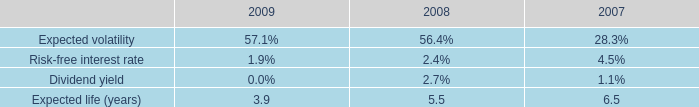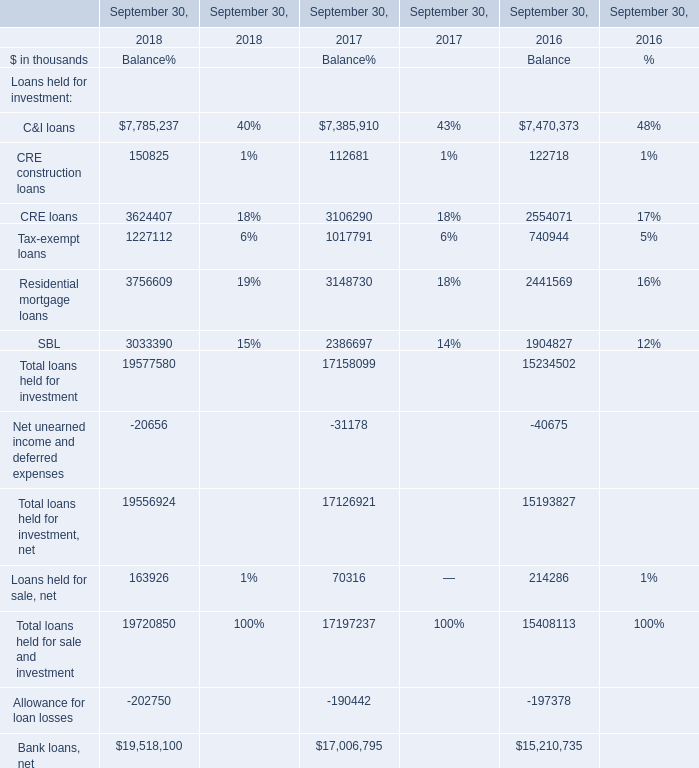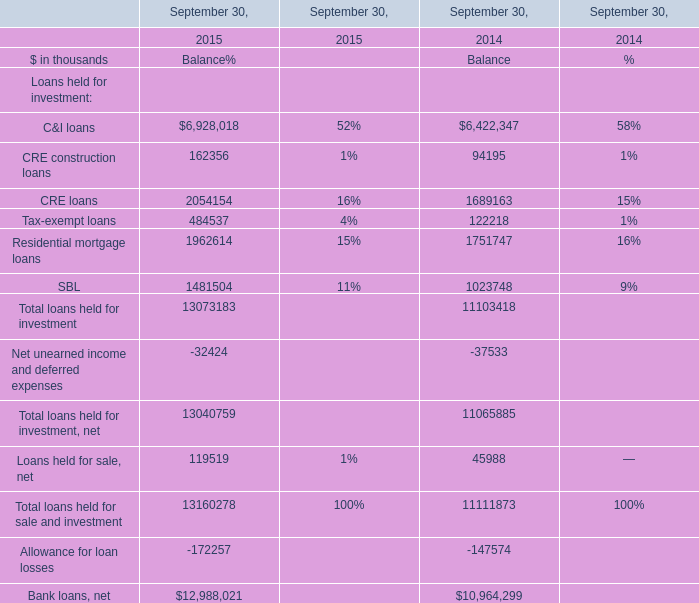What was the average value of the Balance for CRE construction loans, the Balance for CRE loans, the Balance for SBL at September 30,2014? (in thousand) 
Computations: (((94195 + 1689163) + 1023748) / 3)
Answer: 935702.0. 